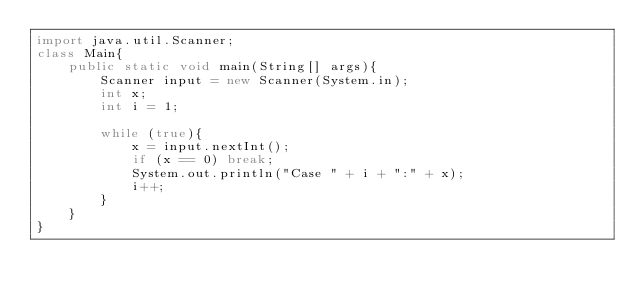Convert code to text. <code><loc_0><loc_0><loc_500><loc_500><_Java_>import java.util.Scanner;
class Main{
	public static void main(String[] args){
		Scanner input = new Scanner(System.in);
		int x;
		int i = 1;
		
		while (true){
			x = input.nextInt();
			if (x == 0)	break;
			System.out.println("Case " + i + ":" + x);
			i++;
		}
	}
}</code> 